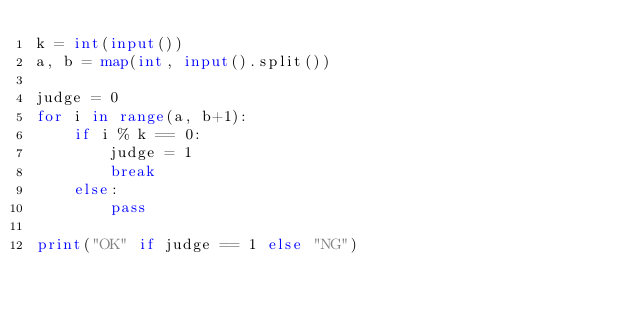Convert code to text. <code><loc_0><loc_0><loc_500><loc_500><_Python_>k = int(input())
a, b = map(int, input().split())

judge = 0
for i in range(a, b+1):
    if i % k == 0:
        judge = 1
        break
    else:
        pass

print("OK" if judge == 1 else "NG")</code> 